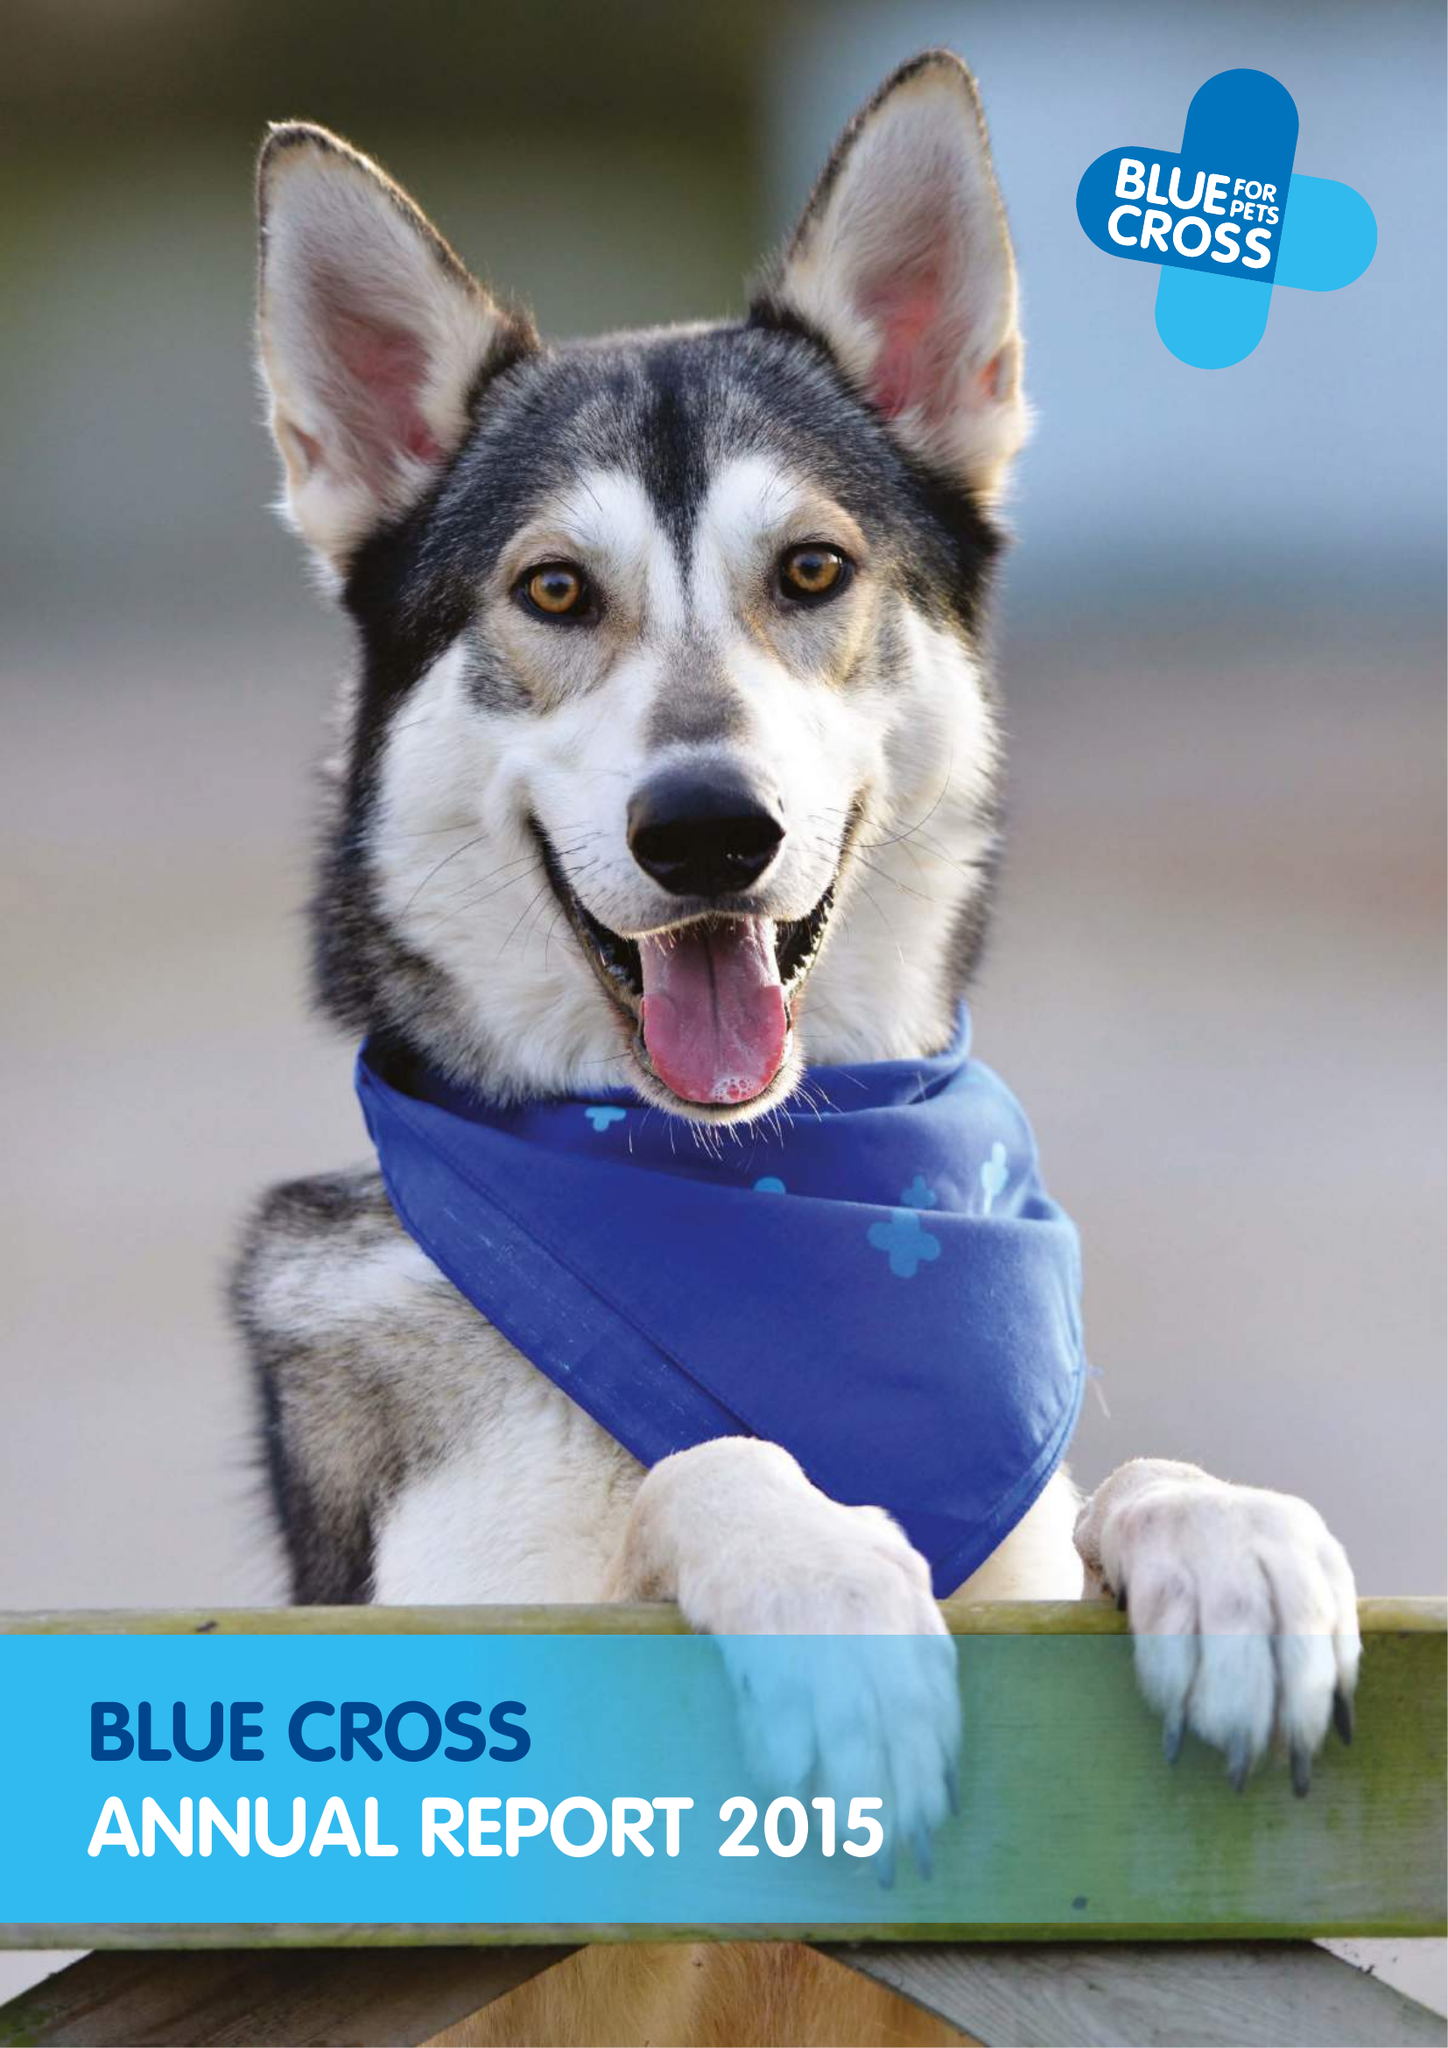What is the value for the address__postcode?
Answer the question using a single word or phrase. OX18 4PF 